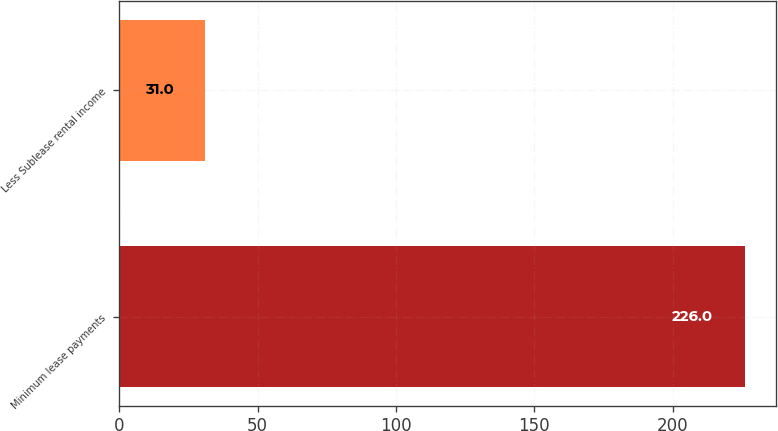<chart> <loc_0><loc_0><loc_500><loc_500><bar_chart><fcel>Minimum lease payments<fcel>Less Sublease rental income<nl><fcel>226<fcel>31<nl></chart> 